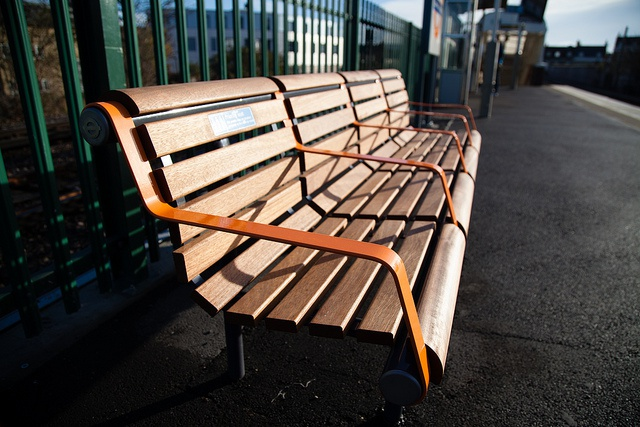Describe the objects in this image and their specific colors. I can see a bench in black, ivory, tan, and gray tones in this image. 